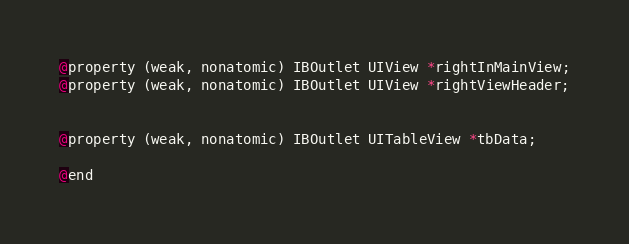<code> <loc_0><loc_0><loc_500><loc_500><_C_>@property (weak, nonatomic) IBOutlet UIView *rightInMainView;
@property (weak, nonatomic) IBOutlet UIView *rightViewHeader;


@property (weak, nonatomic) IBOutlet UITableView *tbData;

@end
</code> 